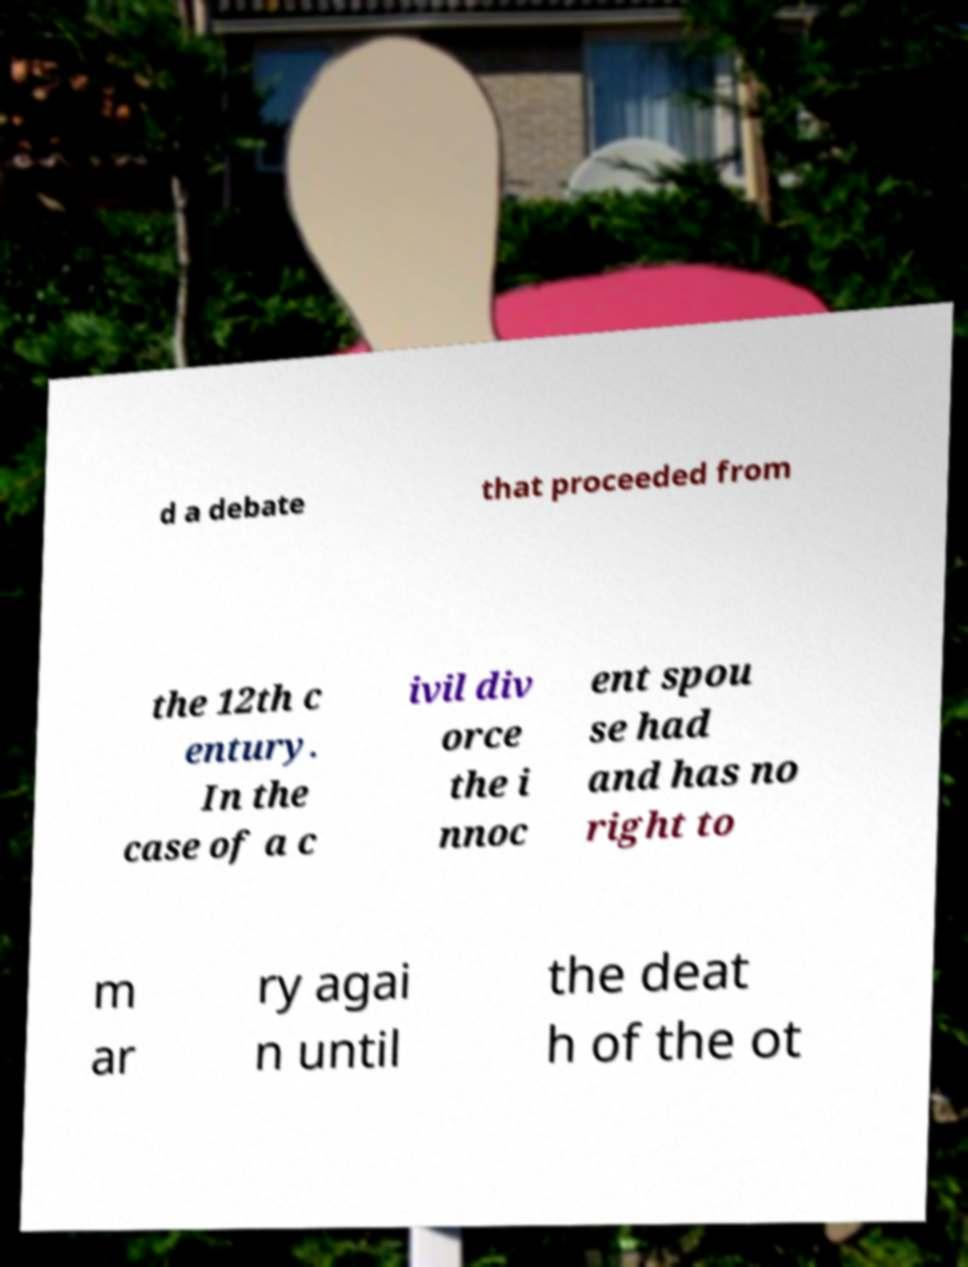Could you assist in decoding the text presented in this image and type it out clearly? d a debate that proceeded from the 12th c entury. In the case of a c ivil div orce the i nnoc ent spou se had and has no right to m ar ry agai n until the deat h of the ot 